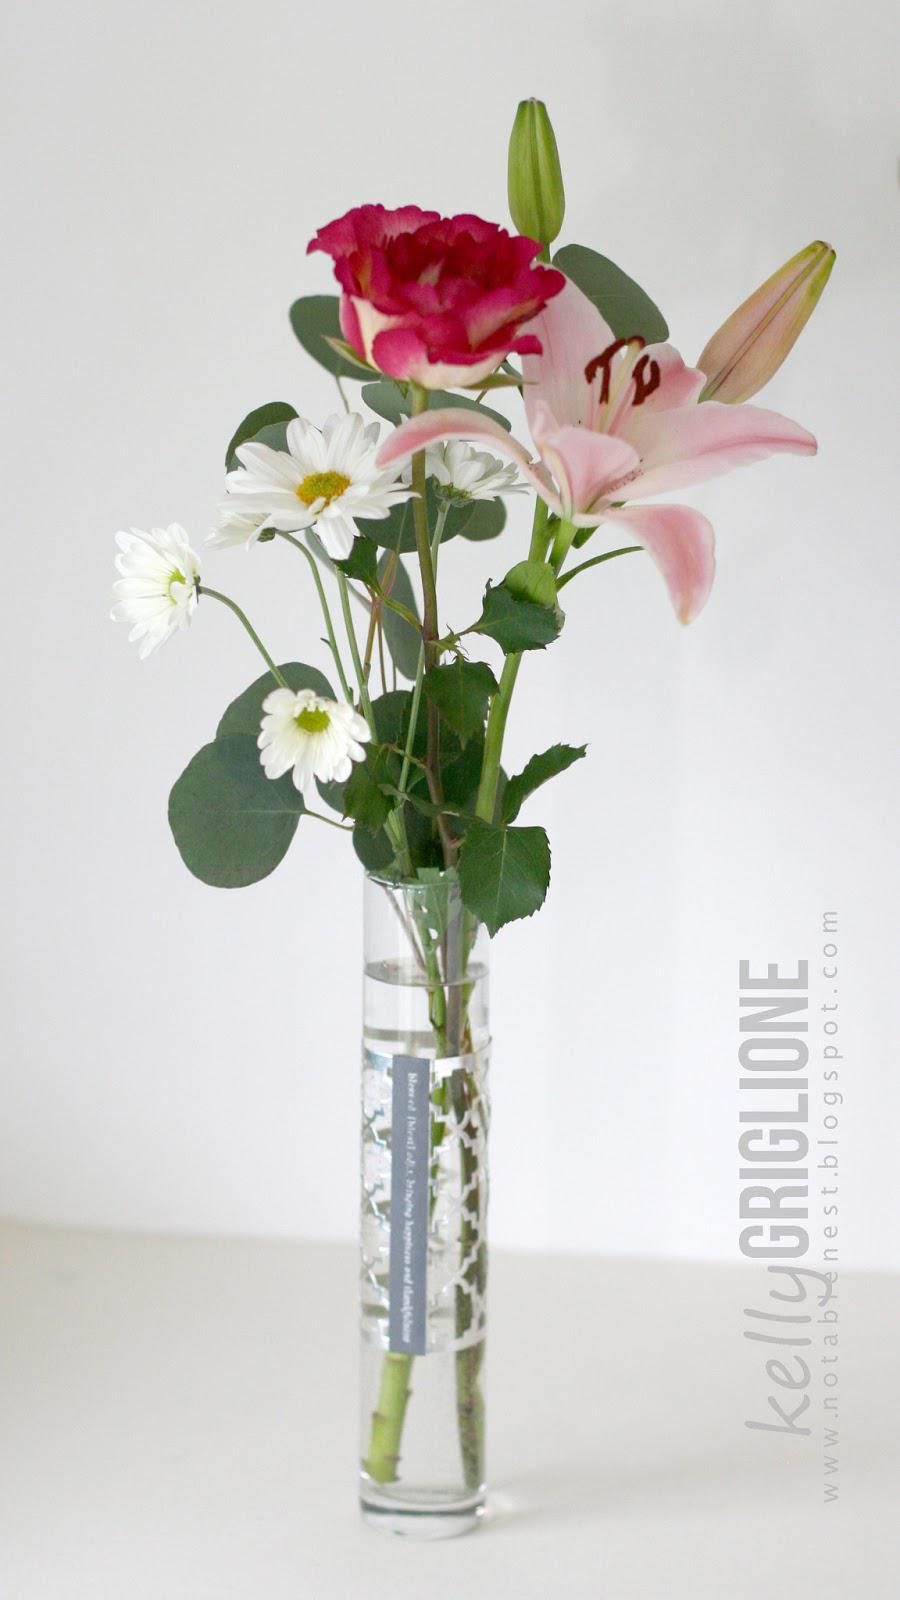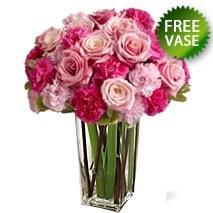The first image is the image on the left, the second image is the image on the right. For the images displayed, is the sentence "One of the vases is purple." factually correct? Answer yes or no. No. 